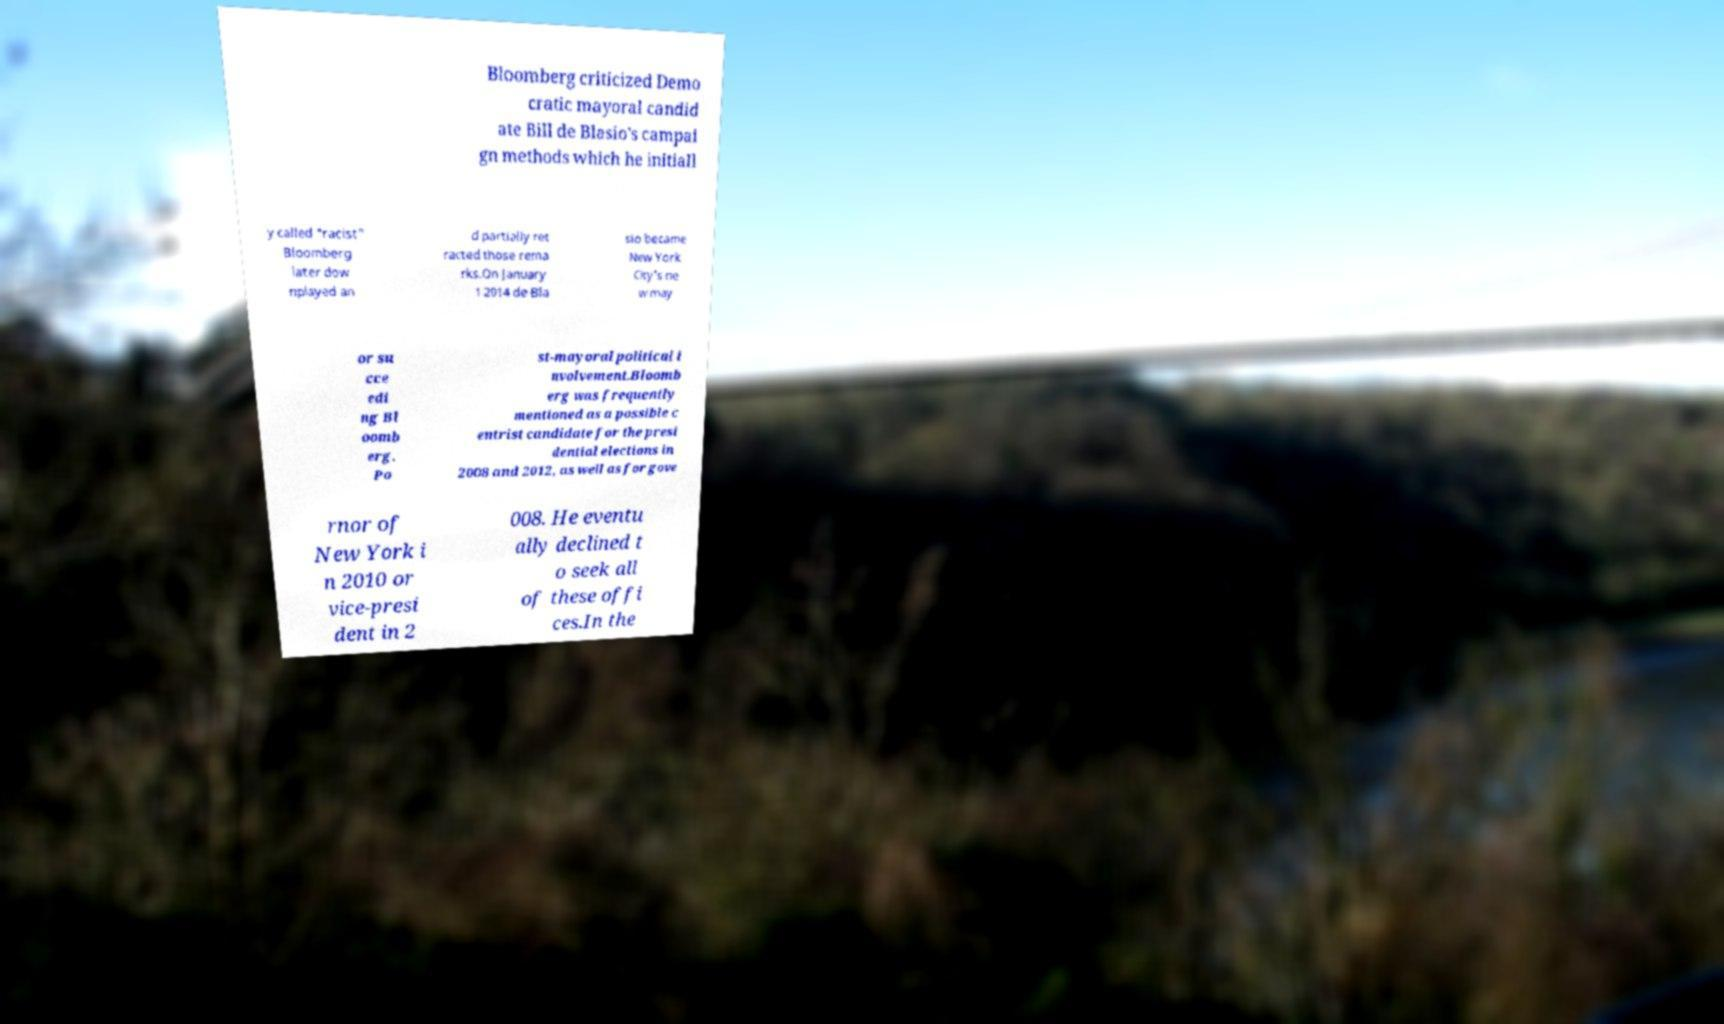Could you extract and type out the text from this image? Bloomberg criticized Demo cratic mayoral candid ate Bill de Blasio's campai gn methods which he initiall y called "racist" Bloomberg later dow nplayed an d partially ret racted those rema rks.On January 1 2014 de Bla sio became New York City's ne w may or su cce edi ng Bl oomb erg. Po st-mayoral political i nvolvement.Bloomb erg was frequently mentioned as a possible c entrist candidate for the presi dential elections in 2008 and 2012, as well as for gove rnor of New York i n 2010 or vice-presi dent in 2 008. He eventu ally declined t o seek all of these offi ces.In the 